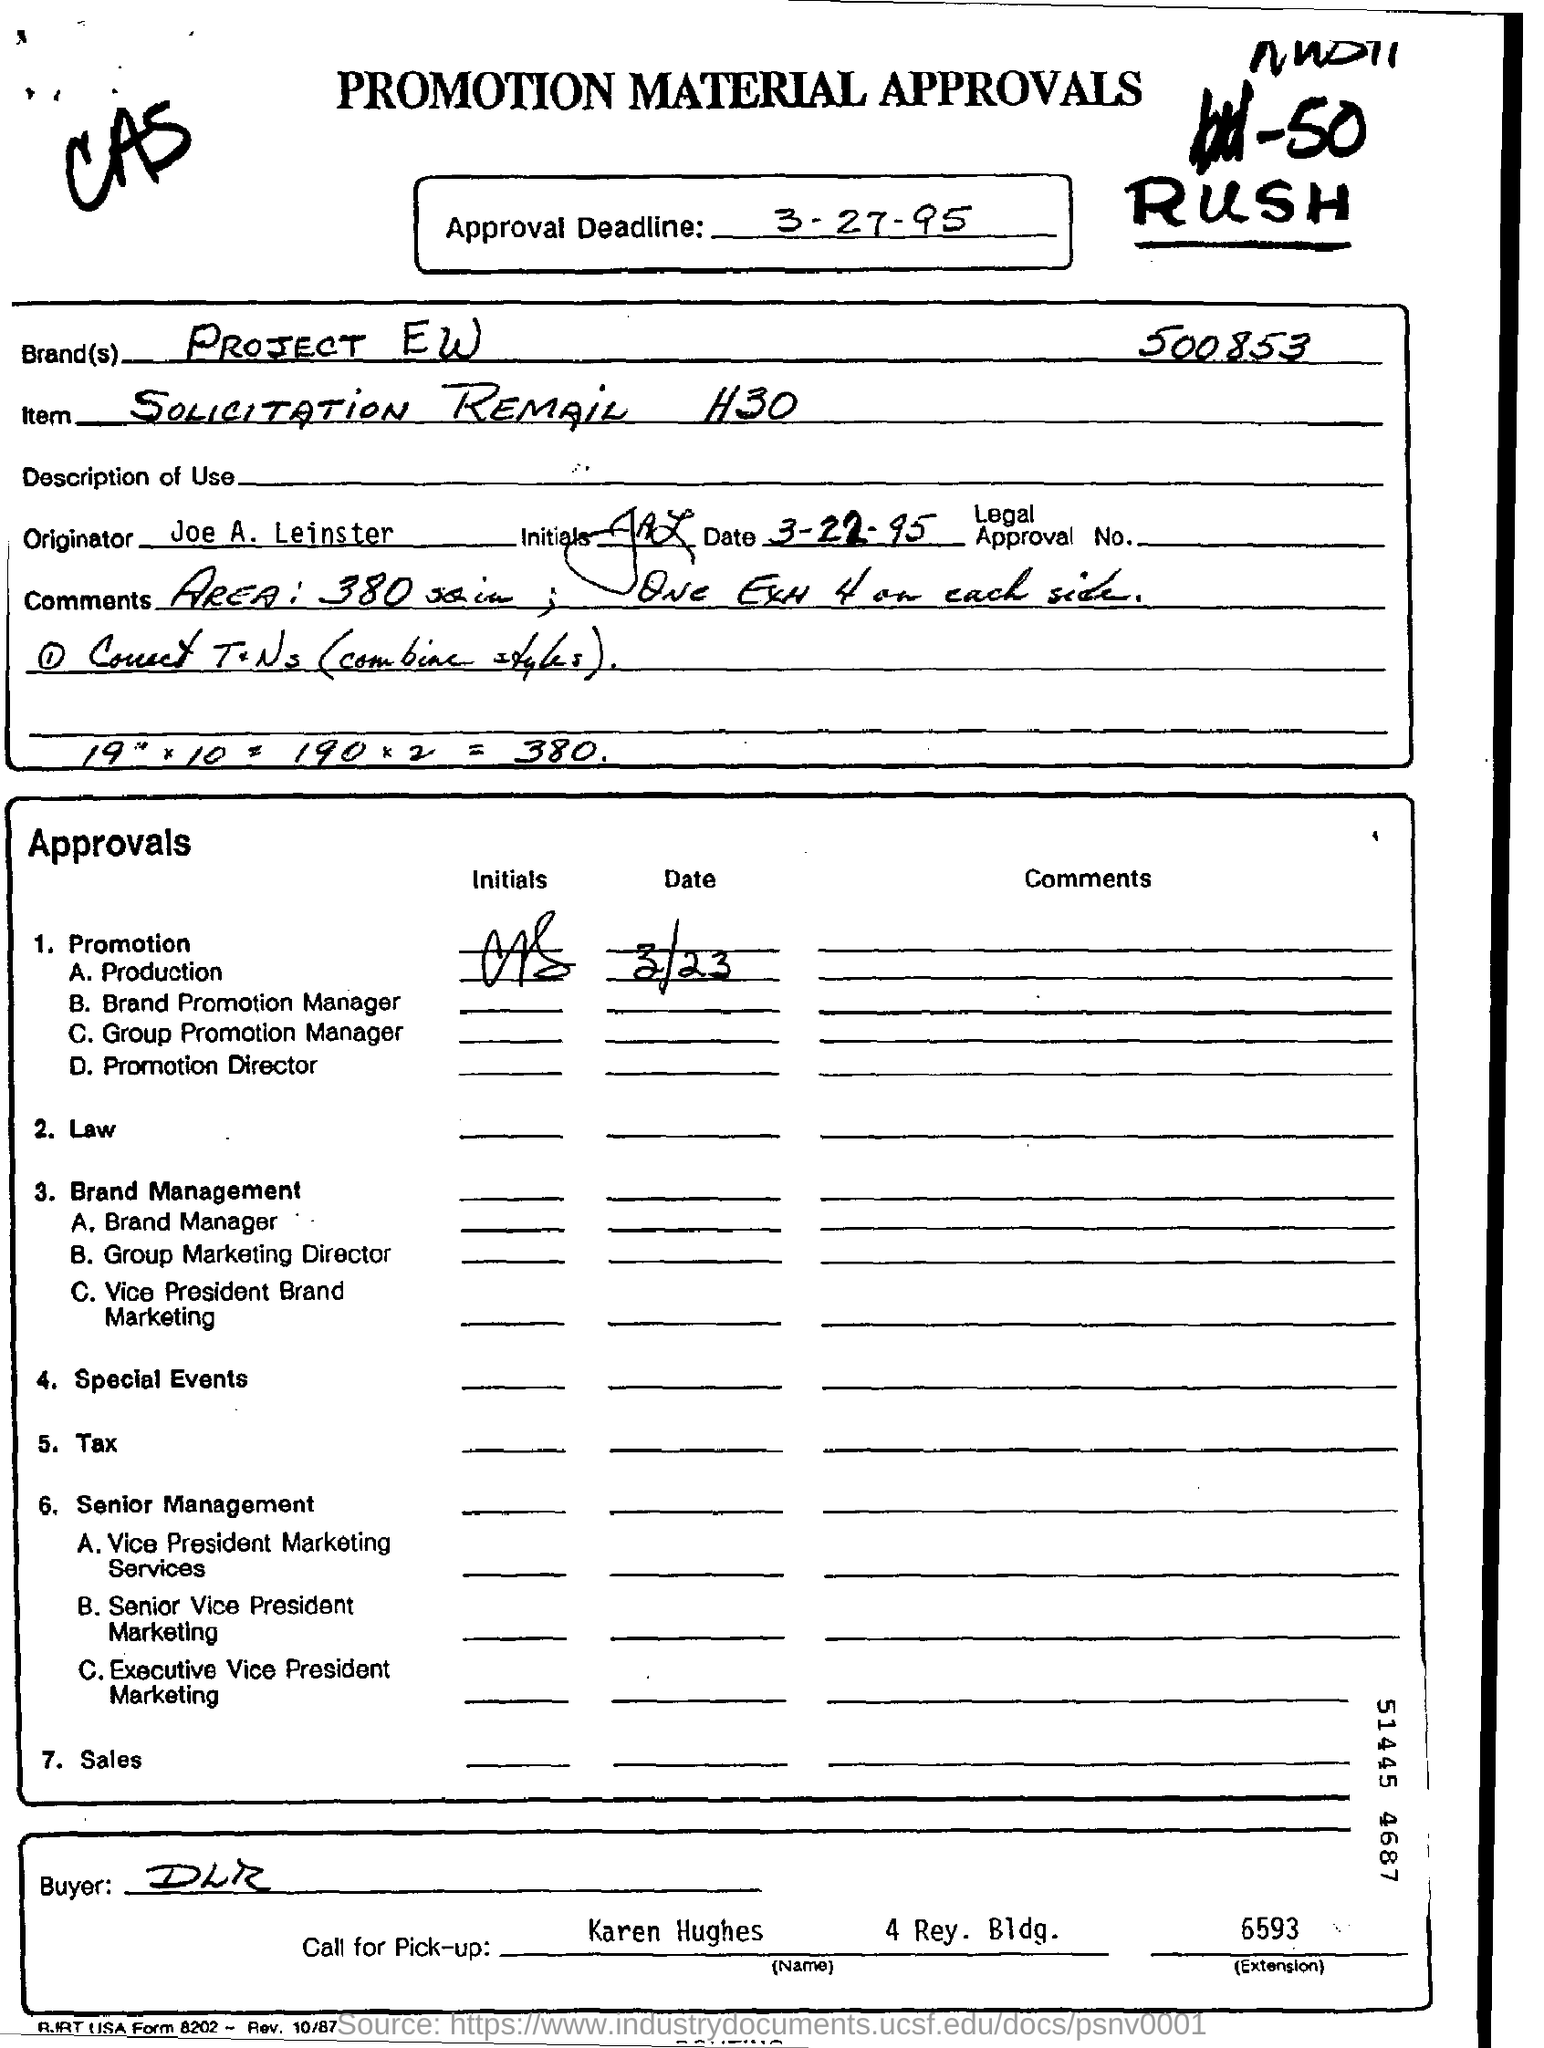Specify some key components in this picture. The name of the buyer is DLR. The name of the originator is Joe A. Leinster. I declare that the brand name is PROJECT EW. The approval deadline is March 27, 1995. 